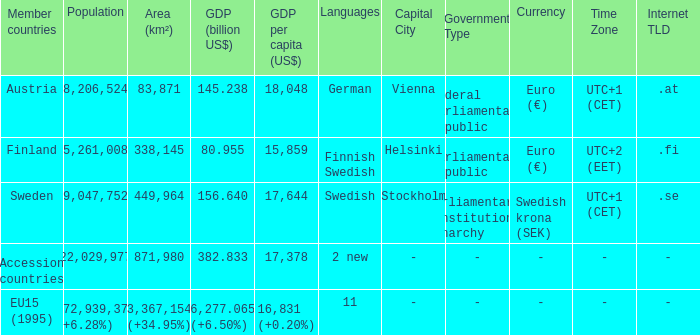Name the population for 11 languages 372,939,379 (+6.28%). 